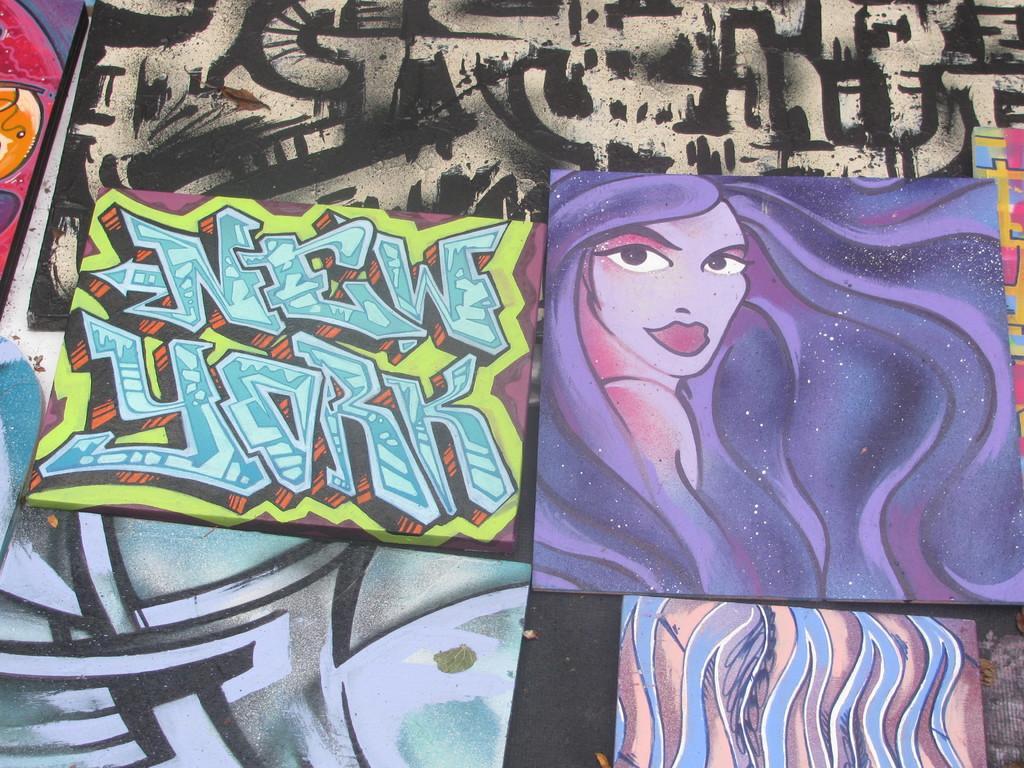In one or two sentences, can you explain what this image depicts? In this picture, we see boards in different colors. These boards have painted cartoons and text. Behind that, we see a wall which is painted and it is known as graffiti. 